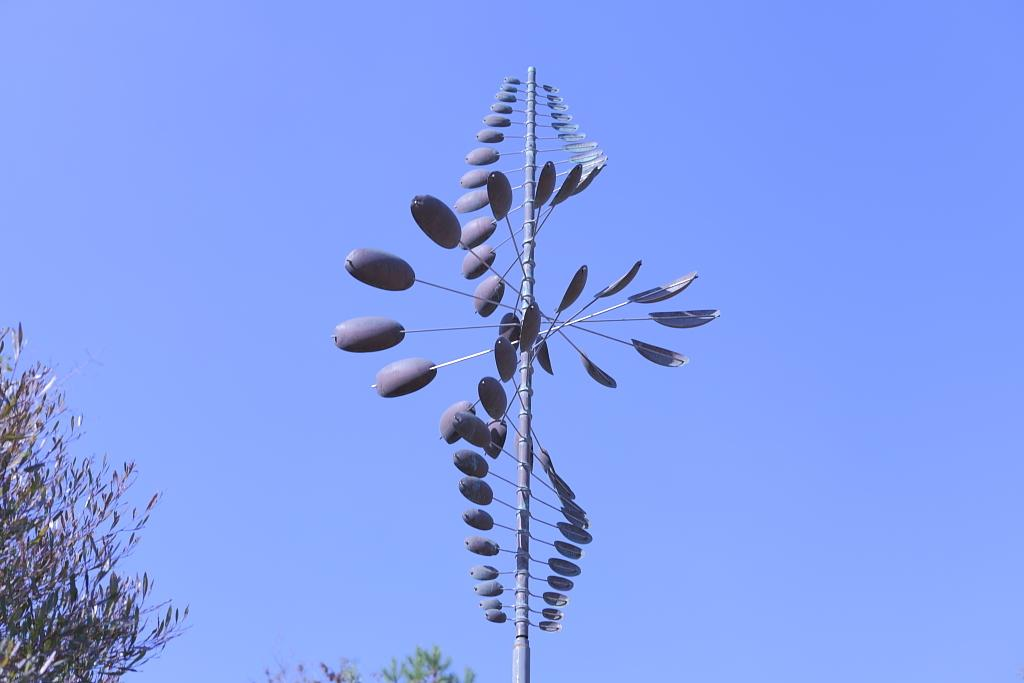What type of sculpture is in the image? There is a copper and steel sculpture in the image. What is the name of the sculpture? The sculpture is called "Twister Oval". What can be seen in the background of the image? There are trees visible in the image. What type of doll is sitting on the plough in the image? There is no doll or plough present in the image; it features a copper and steel sculpture called "Twister Oval" and trees in the background. 